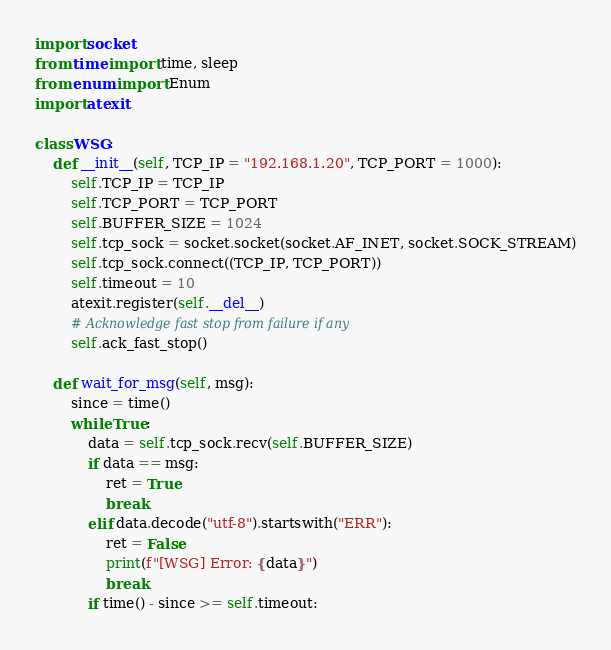Convert code to text. <code><loc_0><loc_0><loc_500><loc_500><_Python_>import socket
from time import time, sleep
from enum import Enum
import atexit

class WSG:
    def __init__(self, TCP_IP = "192.168.1.20", TCP_PORT = 1000):
        self.TCP_IP = TCP_IP
        self.TCP_PORT = TCP_PORT 
        self.BUFFER_SIZE = 1024
        self.tcp_sock = socket.socket(socket.AF_INET, socket.SOCK_STREAM)
        self.tcp_sock.connect((TCP_IP, TCP_PORT))
        self.timeout = 10
        atexit.register(self.__del__)
        # Acknowledge fast stop from failure if any
        self.ack_fast_stop()

    def wait_for_msg(self, msg):
        since = time()
        while True:
            data = self.tcp_sock.recv(self.BUFFER_SIZE)
            if data == msg:
                ret = True
                break
            elif data.decode("utf-8").startswith("ERR"):
                ret = False
                print(f"[WSG] Error: {data}")
                break
            if time() - since >= self.timeout:</code> 